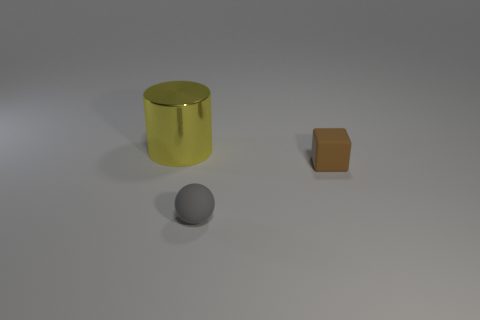Are there any other things that have the same shape as the large yellow object?
Your answer should be compact. No. Are there any other things that are the same size as the shiny cylinder?
Your answer should be compact. No. Are there any yellow objects?
Your answer should be compact. Yes. There is a matte thing behind the small matte object that is in front of the tiny object that is on the right side of the gray matte thing; how big is it?
Your answer should be compact. Small. There is a brown rubber thing that is the same size as the gray matte thing; what shape is it?
Offer a terse response. Cube. Is there any other thing that is made of the same material as the big thing?
Provide a succinct answer. No. How many objects are matte things behind the tiny matte sphere or tiny rubber cubes?
Your response must be concise. 1. There is a tiny thing that is right of the tiny thing in front of the brown block; are there any cylinders that are left of it?
Your response must be concise. Yes. How many tiny purple metallic objects are there?
Make the answer very short. 0. What number of objects are either things behind the tiny matte cube or things to the right of the big yellow metallic thing?
Keep it short and to the point. 3. 